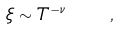Convert formula to latex. <formula><loc_0><loc_0><loc_500><loc_500>\xi \sim T ^ { - \nu } \quad ,</formula> 